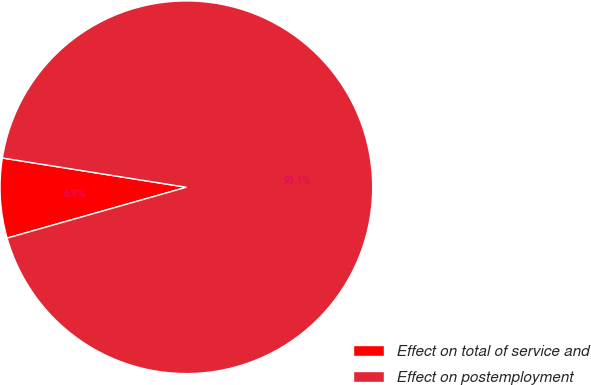Convert chart to OTSL. <chart><loc_0><loc_0><loc_500><loc_500><pie_chart><fcel>Effect on total of service and<fcel>Effect on postemployment<nl><fcel>6.91%<fcel>93.09%<nl></chart> 